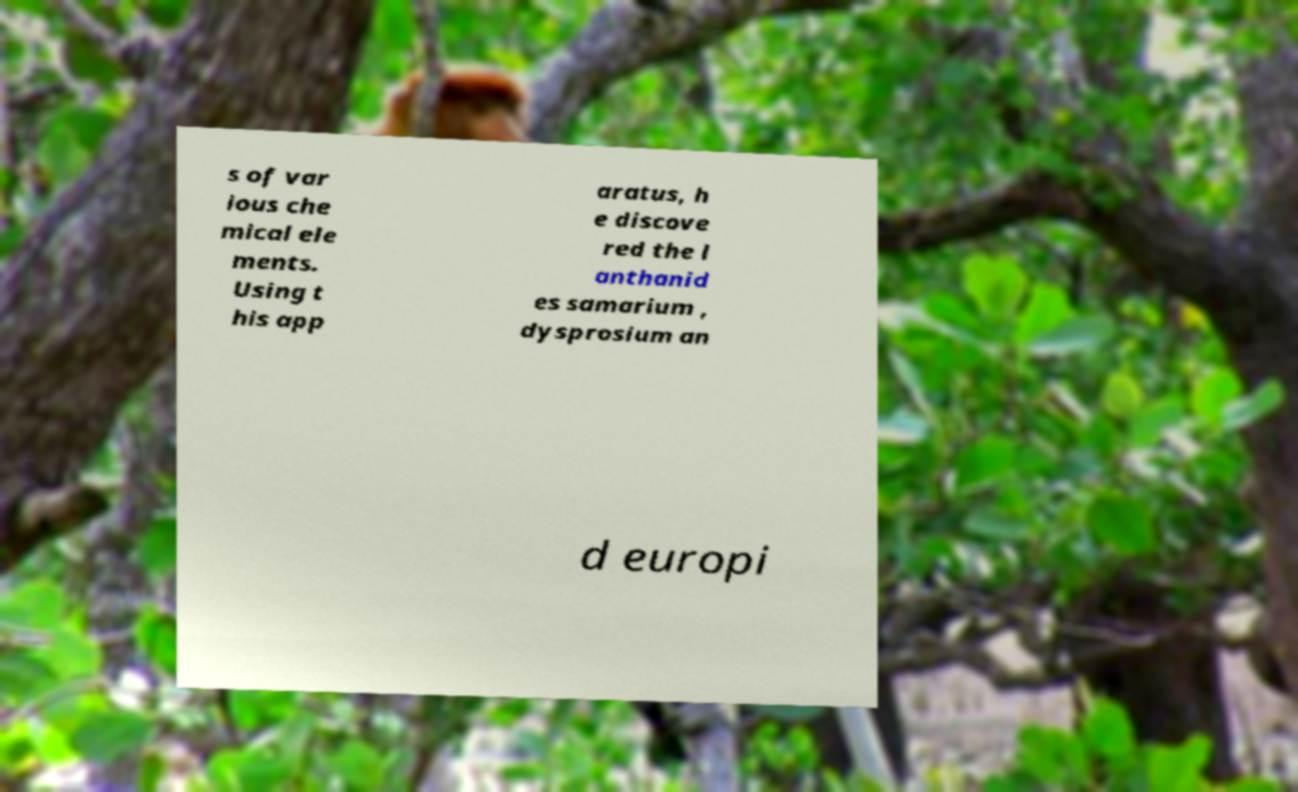Could you assist in decoding the text presented in this image and type it out clearly? s of var ious che mical ele ments. Using t his app aratus, h e discove red the l anthanid es samarium , dysprosium an d europi 